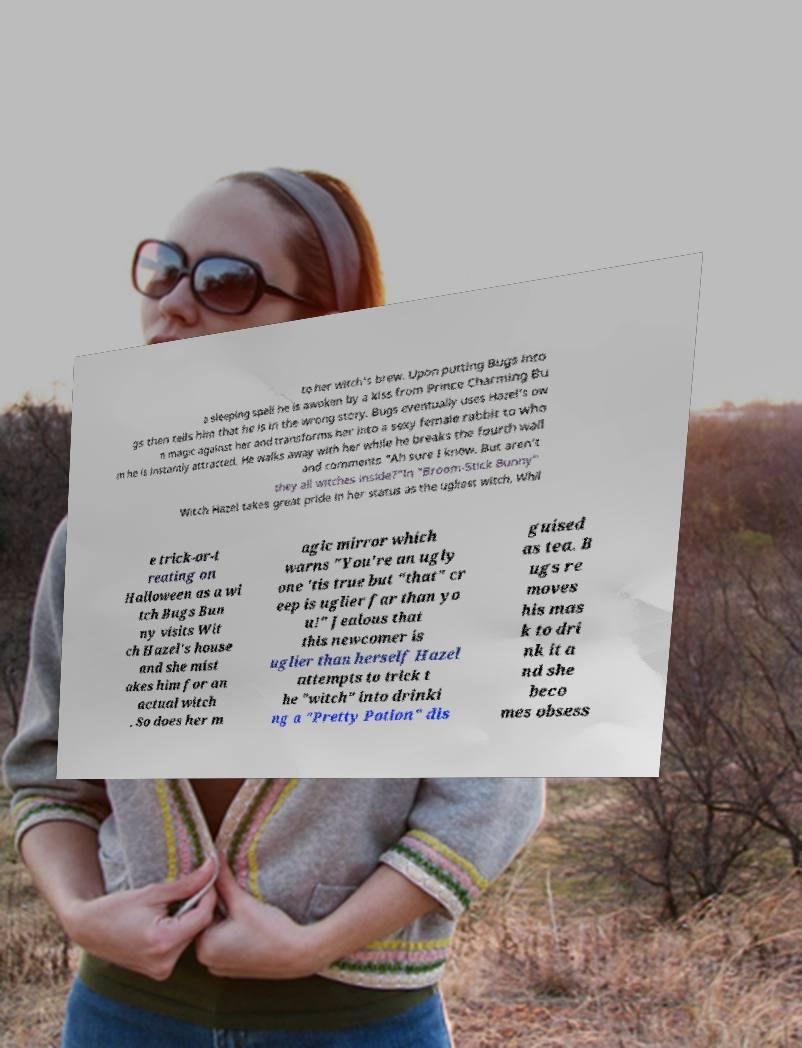Can you read and provide the text displayed in the image?This photo seems to have some interesting text. Can you extract and type it out for me? to her witch's brew. Upon putting Bugs into a sleeping spell he is awoken by a kiss from Prince Charming Bu gs then tells him that he is in the wrong story. Bugs eventually uses Hazel's ow n magic against her and transforms her into a sexy female rabbit to who m he is instantly attracted. He walks away with her while he breaks the fourth wall and comments "Ah sure I know. But aren't they all witches inside?"In "Broom-Stick Bunny" Witch Hazel takes great pride in her status as the ugliest witch. Whil e trick-or-t reating on Halloween as a wi tch Bugs Bun ny visits Wit ch Hazel's house and she mist akes him for an actual witch . So does her m agic mirror which warns "You're an ugly one 'tis true but "that" cr eep is uglier far than yo u!" Jealous that this newcomer is uglier than herself Hazel attempts to trick t he "witch" into drinki ng a "Pretty Potion" dis guised as tea. B ugs re moves his mas k to dri nk it a nd she beco mes obsess 